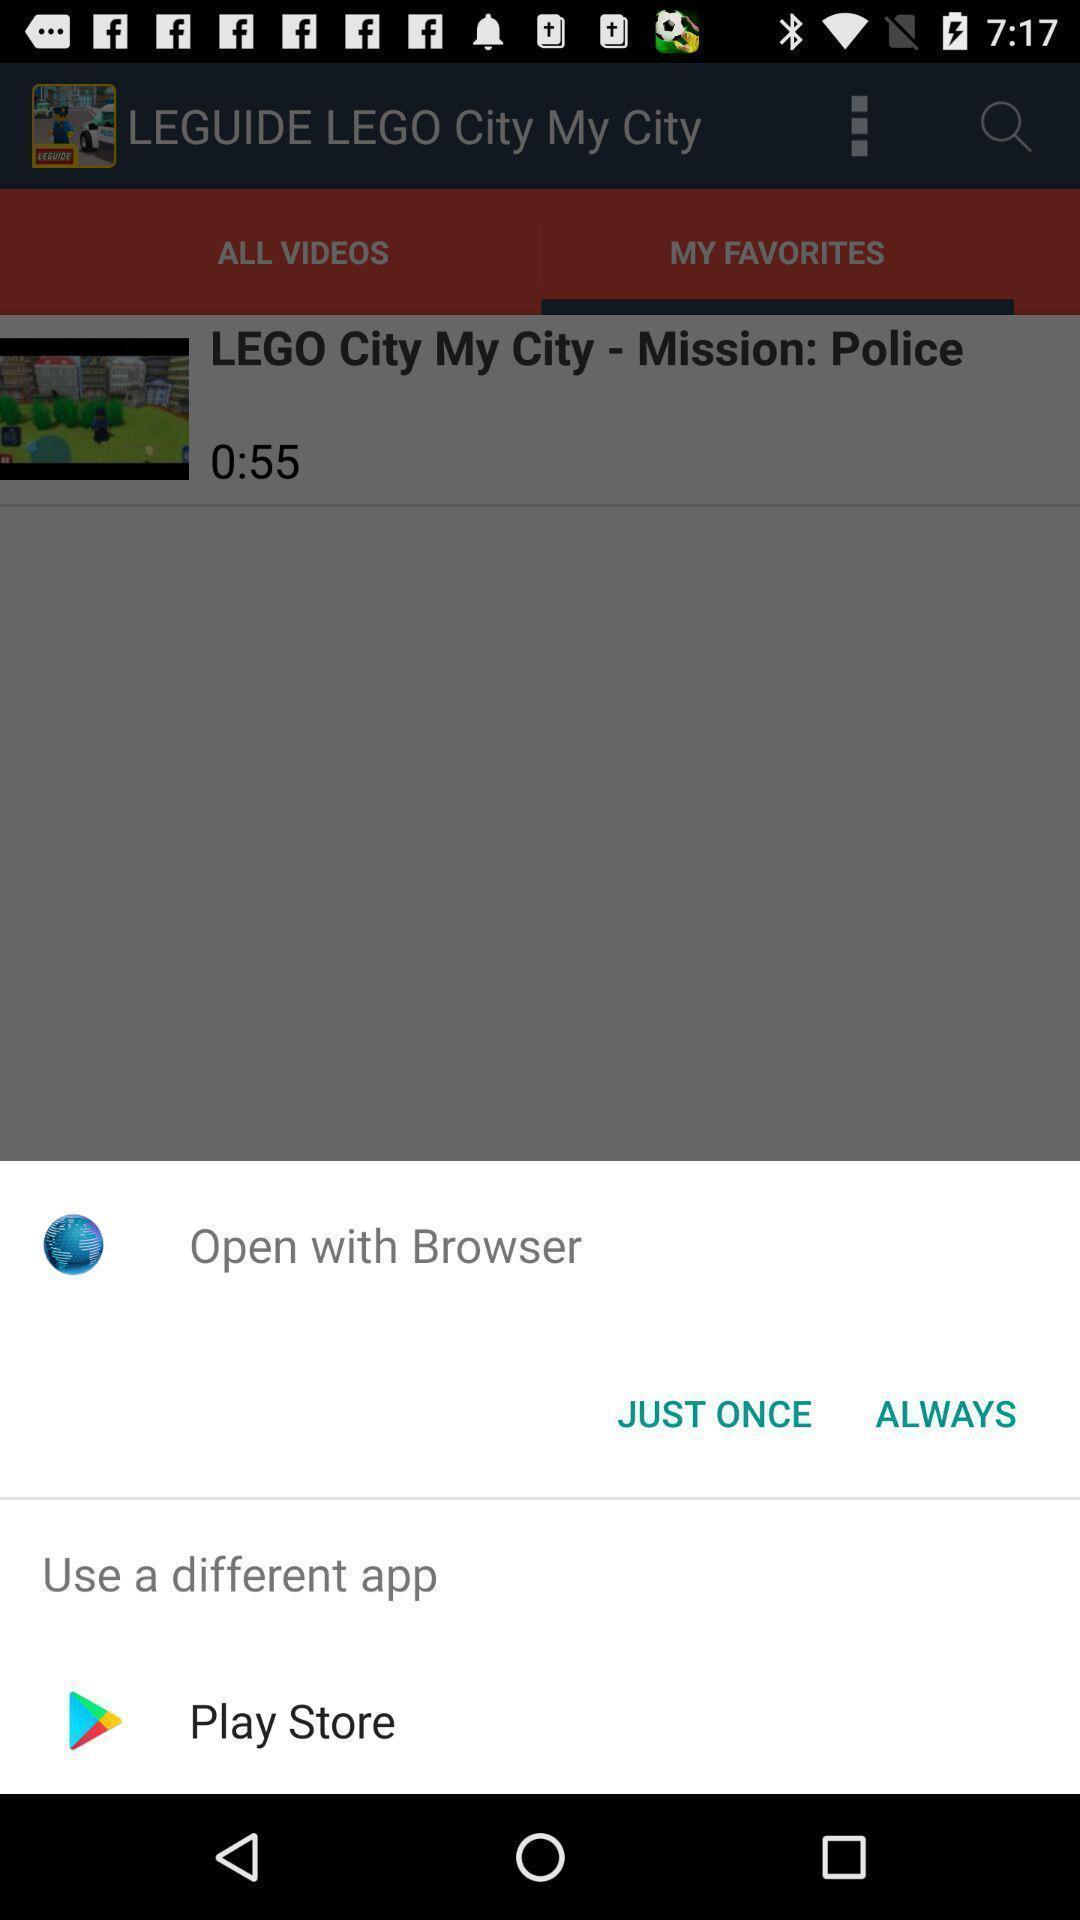Provide a description of this screenshot. Pop-up of a browser to open with. 